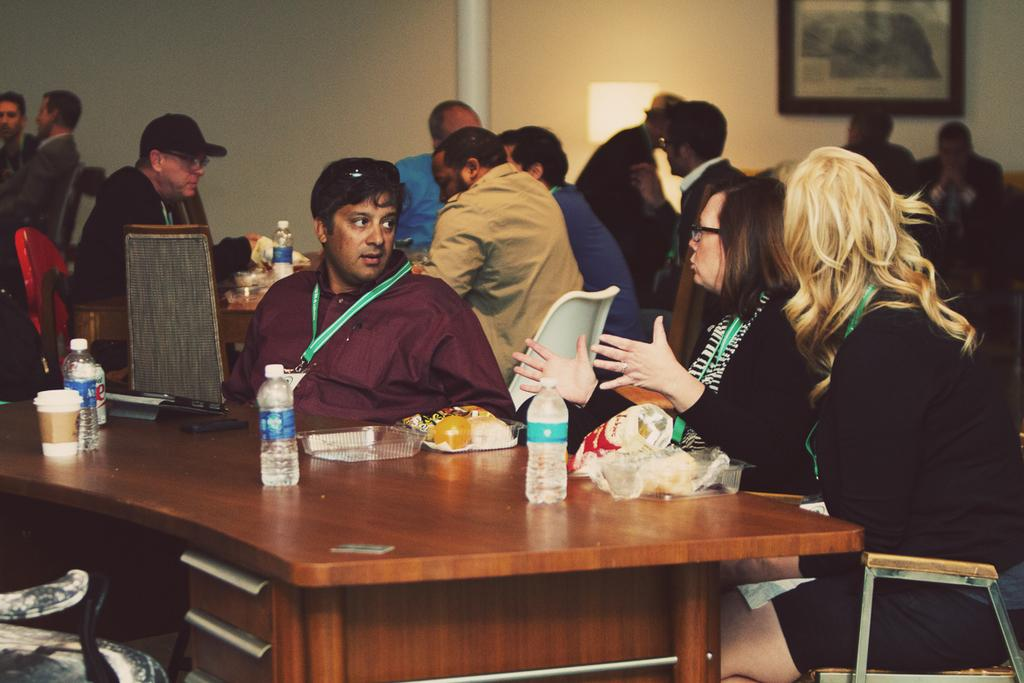What are the people in the image doing? The people in the image are sitting on chairs. What is present on the table in the image? There is a laptop, a chips packet, and a coffee cup on the table. What is the primary object on the table? The primary object on the table is a laptop. How many passengers are visible in the image? There is no reference to passengers in the image, as it features people sitting on chairs and objects on a table. 